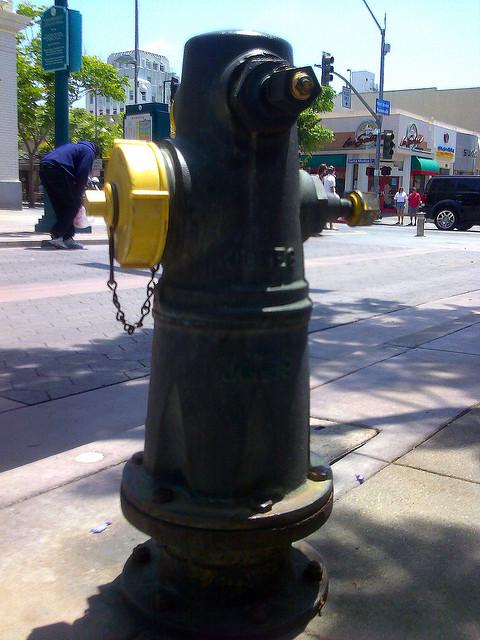What is the hydrant made of?
Short answer required. Metal. Is the hydrant all one color?
Concise answer only. No. What is the man in the blue shirt doing?
Give a very brief answer. Bending over. 